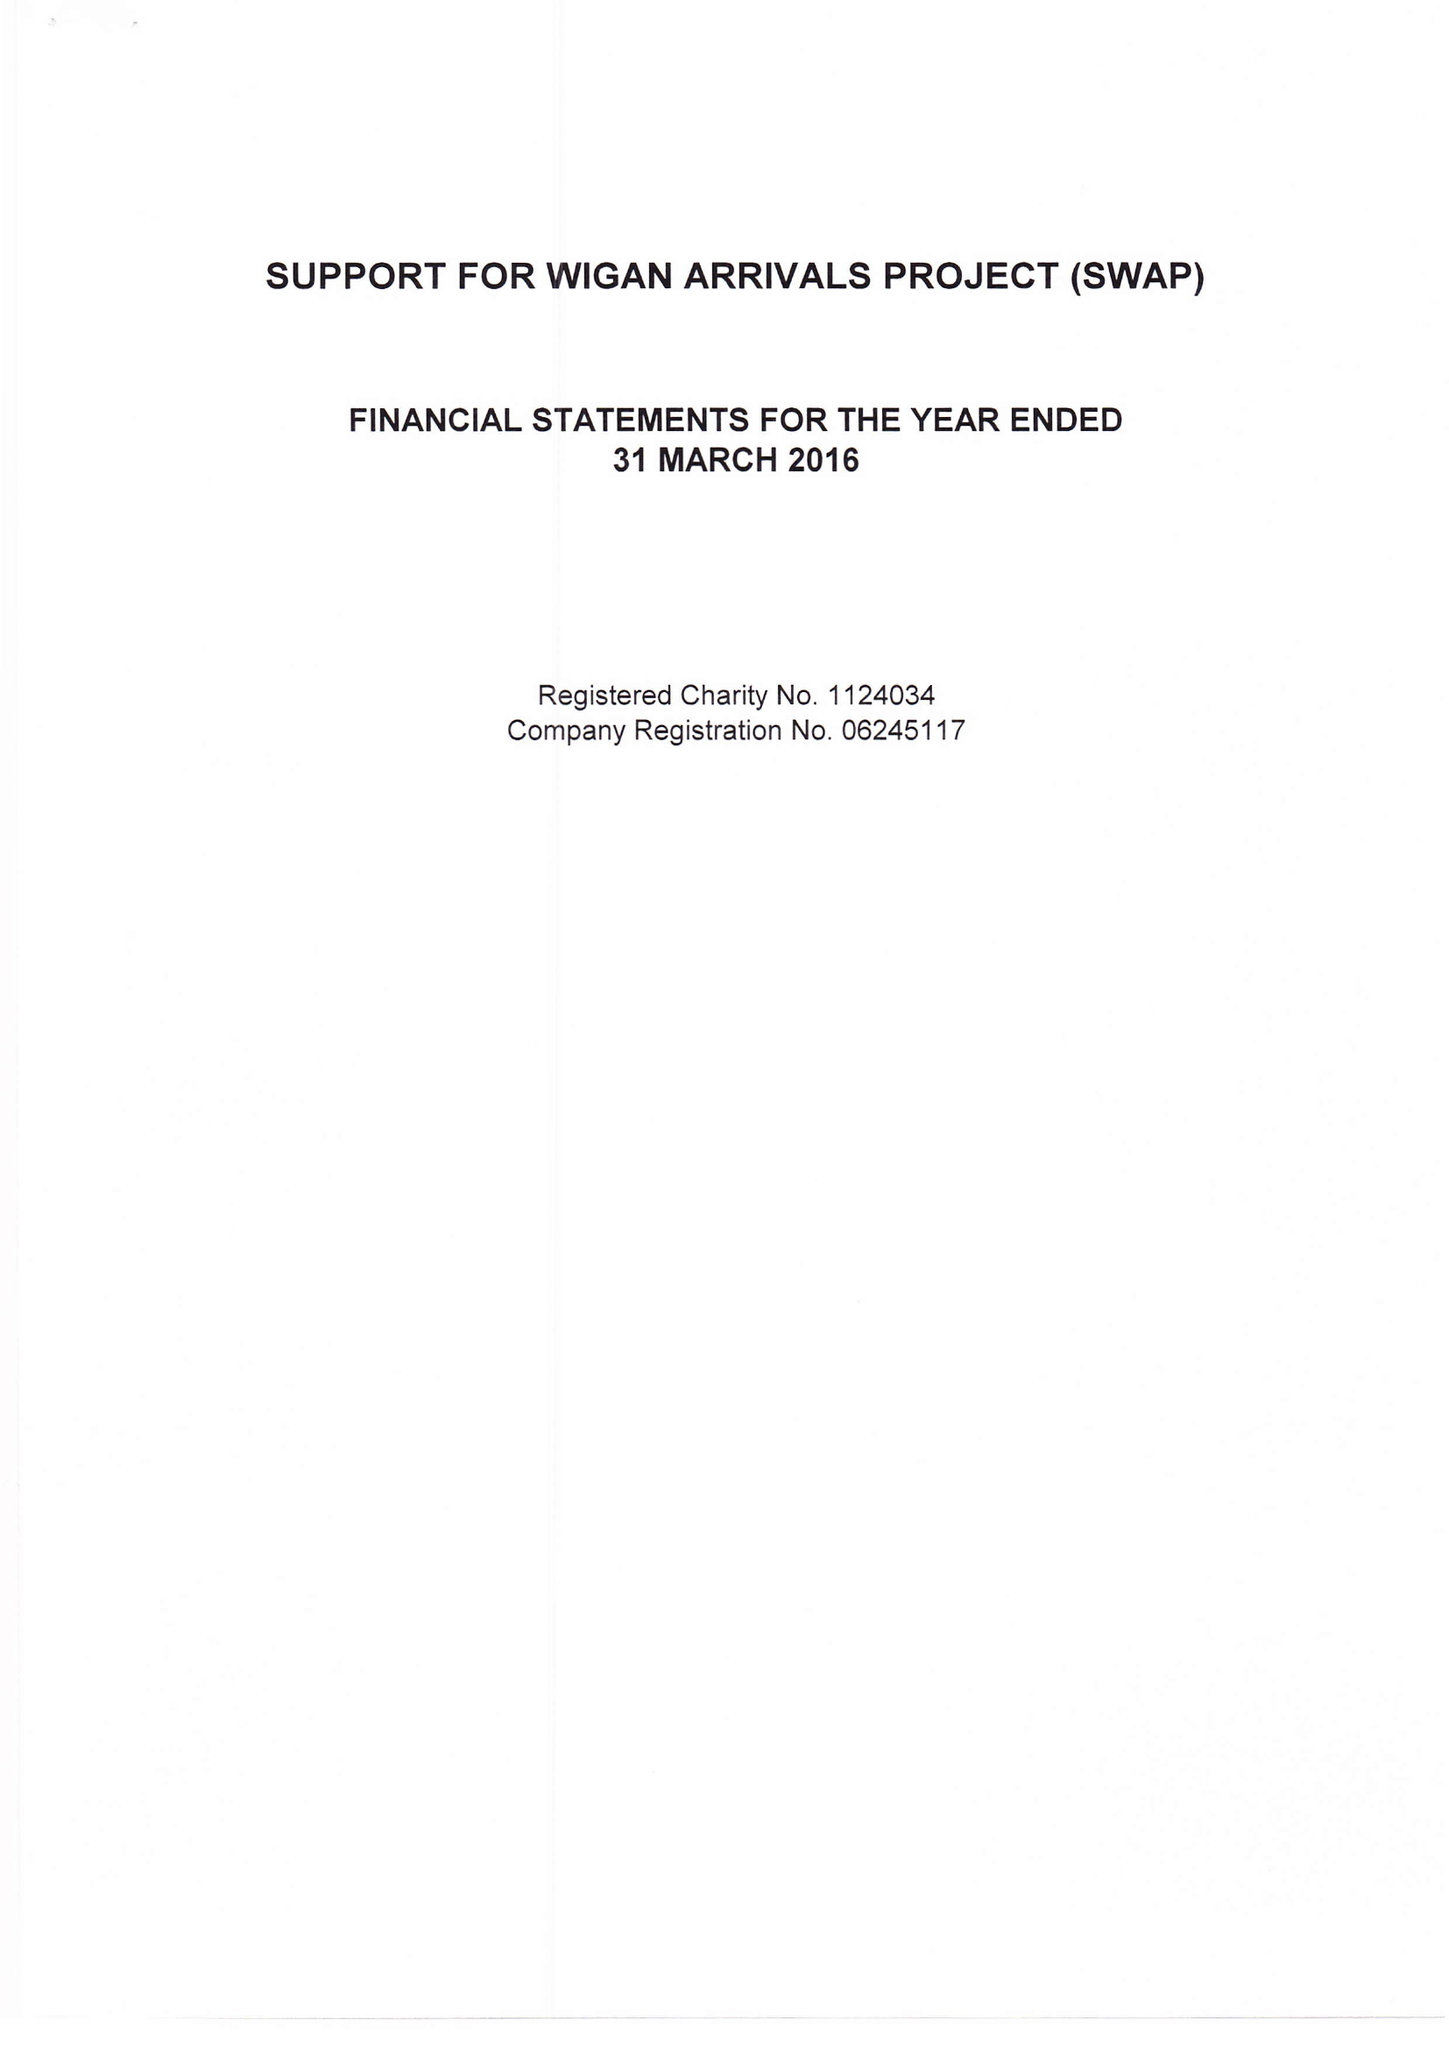What is the value for the address__postcode?
Answer the question using a single word or phrase. WN1 2LP 